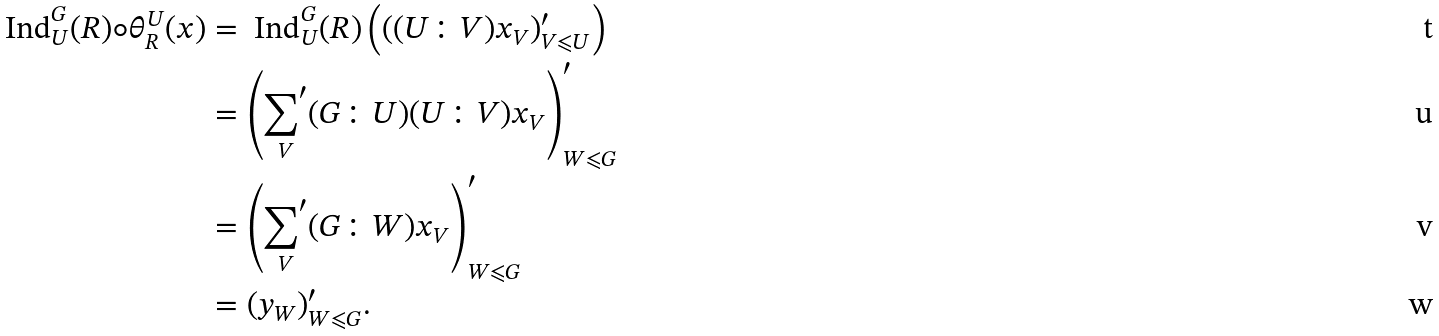Convert formula to latex. <formula><loc_0><loc_0><loc_500><loc_500>\text { Ind} _ { U } ^ { G } ( R ) \circ \theta _ { R } ^ { U } ( { x } ) & = \text { Ind} _ { U } ^ { G } ( R ) \left ( ( ( U \colon V ) x _ { V } ) ^ { \prime } _ { V \leqslant U } \right ) \\ & = \left ( \underset { V } { { \sum } ^ { \prime } } ( G \colon U ) ( U \colon V ) x _ { V } \right ) ^ { \prime } _ { W \leqslant G } \\ & = \left ( \underset { V } { { \sum } ^ { \prime } } ( G \colon W ) x _ { V } \right ) ^ { \prime } _ { W \leqslant G } \\ & = ( y _ { W } ) ^ { \prime } _ { W \leqslant G } .</formula> 